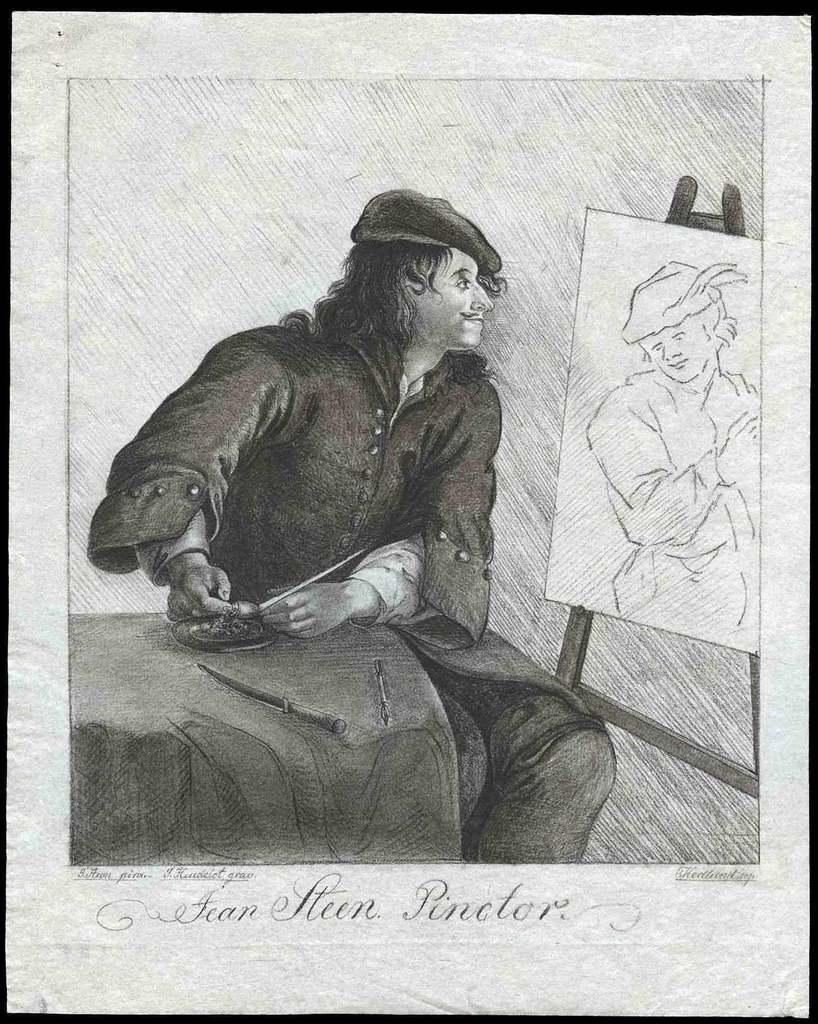Could you give a brief overview of what you see in this image? In the image we can see a frame. In the frame we can see a drawing and there are some alphabets. 